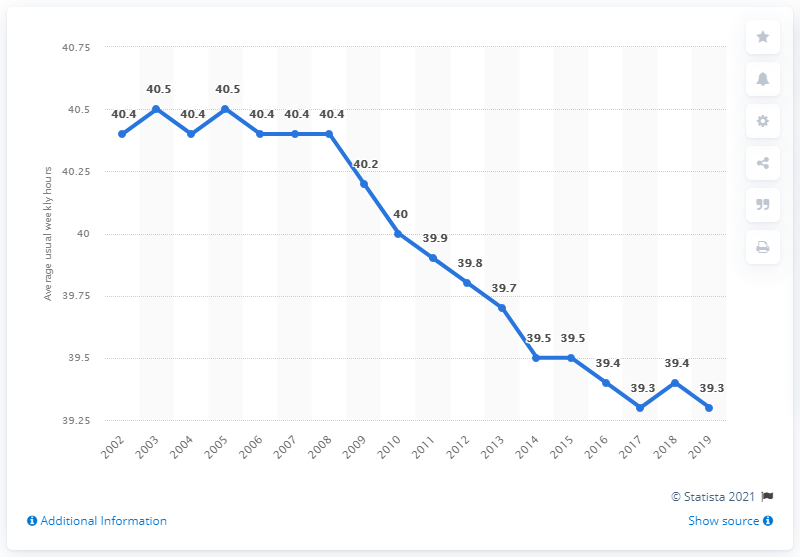Highlight a few significant elements in this photo. In 2019, the average number of weekly hours worked was 39.3 hours. According to data from 2003 and 2005, the average weekly working hours in the Czech Republic was 40.5 hours. In how many years did people work more than 40 hours per week? 8 years. The value of 39.7 years is equivalent to 1 unit. 